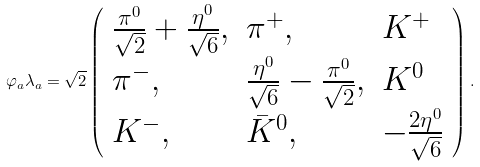<formula> <loc_0><loc_0><loc_500><loc_500>\varphi _ { a } \lambda _ { a } = \sqrt { 2 } \left ( \begin{array} { l l l } \frac { \pi ^ { 0 } } { \sqrt { 2 } } + \frac { \eta ^ { 0 } } { \sqrt { 6 } } , & \pi ^ { + } , & K ^ { + } \\ \pi ^ { - } , & \frac { \eta ^ { 0 } } { \sqrt { 6 } } - \frac { \pi ^ { 0 } } { \sqrt { 2 } } , & K ^ { 0 } \\ K ^ { - } , & \bar { K } ^ { 0 } , & - \frac { 2 \eta ^ { 0 } } { \sqrt { 6 } } \end{array} \right ) .</formula> 